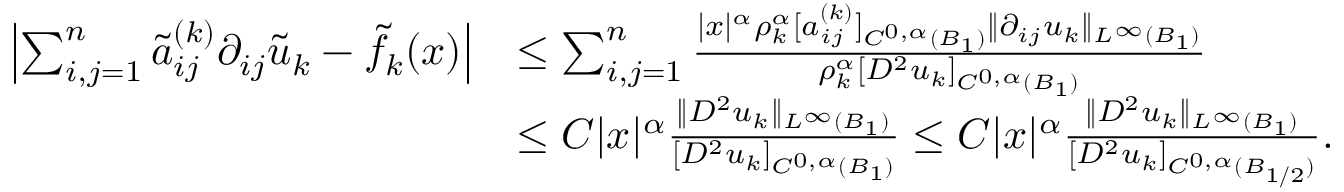<formula> <loc_0><loc_0><loc_500><loc_500>\begin{array} { r l } { \left | \sum _ { i , j = 1 } ^ { n } \tilde { a } _ { i j } ^ { ( k ) } \partial _ { i j } \tilde { u } _ { k } - \tilde { f } _ { k } ( x ) \right | } & { \leq \sum _ { i , j = 1 } ^ { n } \frac { | x | ^ { \alpha } \rho _ { k } ^ { \alpha } [ a _ { i j } ^ { ( k ) } ] _ { C ^ { 0 , \alpha } ( B _ { 1 } ) } \| \partial _ { i j } u _ { k } \| _ { L ^ { \infty } ( B _ { 1 } ) } } { \rho _ { k } ^ { \alpha } [ D ^ { 2 } u _ { k } ] _ { C ^ { 0 , \alpha } ( B _ { 1 } ) } } } \\ & { \leq C | x | ^ { \alpha } \frac { \| D ^ { 2 } u _ { k } \| _ { L ^ { \infty } ( B _ { 1 } ) } } { [ D ^ { 2 } u _ { k } ] _ { C ^ { 0 , \alpha } ( B _ { 1 } ) } } \leq C | x | ^ { \alpha } \frac { \| D ^ { 2 } u _ { k } \| _ { L ^ { \infty } ( B _ { 1 } ) } } { [ D ^ { 2 } u _ { k } ] _ { C ^ { 0 , \alpha } ( B _ { 1 / 2 } ) } } . } \end{array}</formula> 